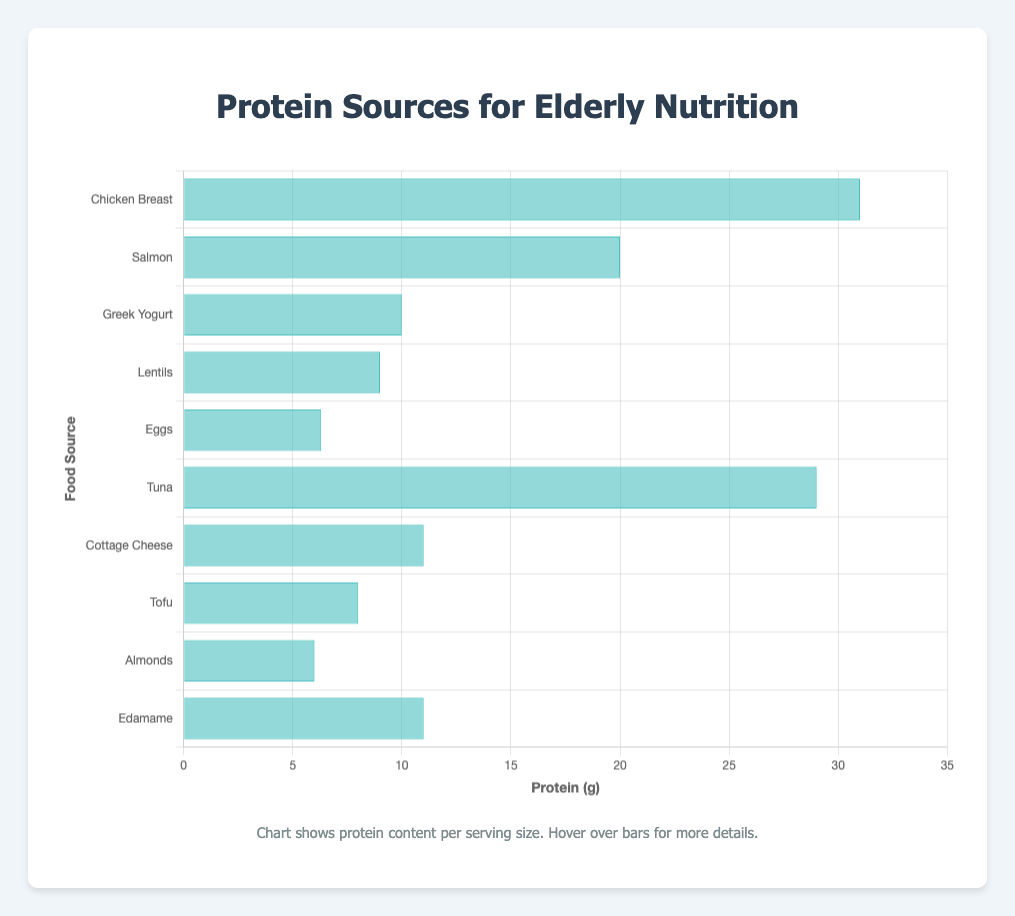What food source has the highest protein content per serving? The bar for 'Chicken Breast' is the tallest, representing 31 grams of protein per serving size. Therefore, 'Chicken Breast' has the highest protein content per serving.
Answer: Chicken Breast Which food source has more protein: Tuna or Salmon? By comparing the lengths of the bars, we see that 'Tuna' has a longer bar (29 grams) compared to 'Salmon' (20 grams) in terms of protein content per serving.
Answer: Tuna Which food items have the same amount of protein per serving? 'Cottage Cheese' and 'Edamame' both have bars of equal length, each representing 11 grams of protein per serving, suggesting they have the same amount of protein per serving.
Answer: Cottage Cheese and Edamame How many grams of protein are in 200 grams of Greek Yogurt? The protein content of Greek Yogurt is 10 grams per 100 grams. For 200 grams, multiply the protein content by 2 (10 grams × 2) to get 20 grams of protein.
Answer: 20 grams What is the total protein content for Chicken Breast and Tofu combined? The protein content for 'Chicken Breast' is 31 grams and for 'Tofu' is 8 grams. Adding these together (31 + 8), the total protein content is 39 grams.
Answer: 39 grams Which has fewer calories per given serving, Greek Yogurt or Lentils? According to the tooltip data, 'Greek Yogurt' has 59 calories, while 'Lentils' have 116 calories per serving. Thus, Greek Yogurt has fewer calories.
Answer: Greek Yogurt Are the servings sizes for all the food sources the same in the chart? The bar chart visualization only indicates the protein amount visually, but serving sizes noted in the data show that food items like 'Eggs' and 'Almonds' have different serving sizes (50 grams for Eggs, 28 grams for Almonds, etc.).
Answer: No What is the difference in protein content between Chicken Breast and Edamame? The protein for 'Chicken Breast' is 31 grams, and for 'Edamame' is 11 grams. Subtracting these (31 - 11), we get a 20 grams difference in protein content.
Answer: 20 grams Which food source contains the least protein per serving? The shortest bar in the chart represents 'Almonds', with 6 grams of protein per serving, making it the food with the least amount of protein per serving.
Answer: Almonds Which food item has the highest fat content according to the tooltip? By hovering over the bars and examining the tooltip data, 'Salmon' has the highest fat content at 13 grams per serving.
Answer: Salmon 